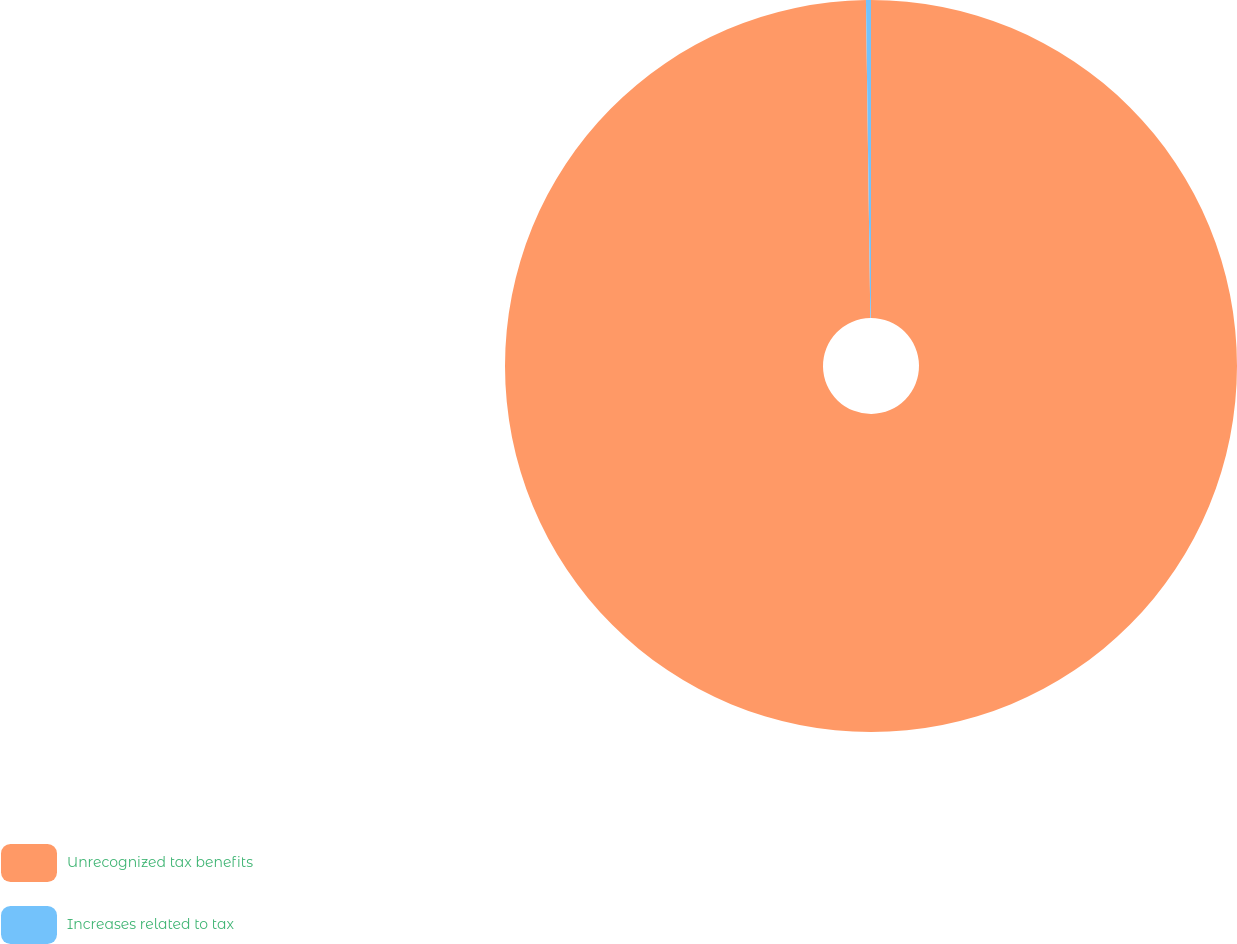<chart> <loc_0><loc_0><loc_500><loc_500><pie_chart><fcel>Unrecognized tax benefits<fcel>Increases related to tax<nl><fcel>99.78%<fcel>0.22%<nl></chart> 